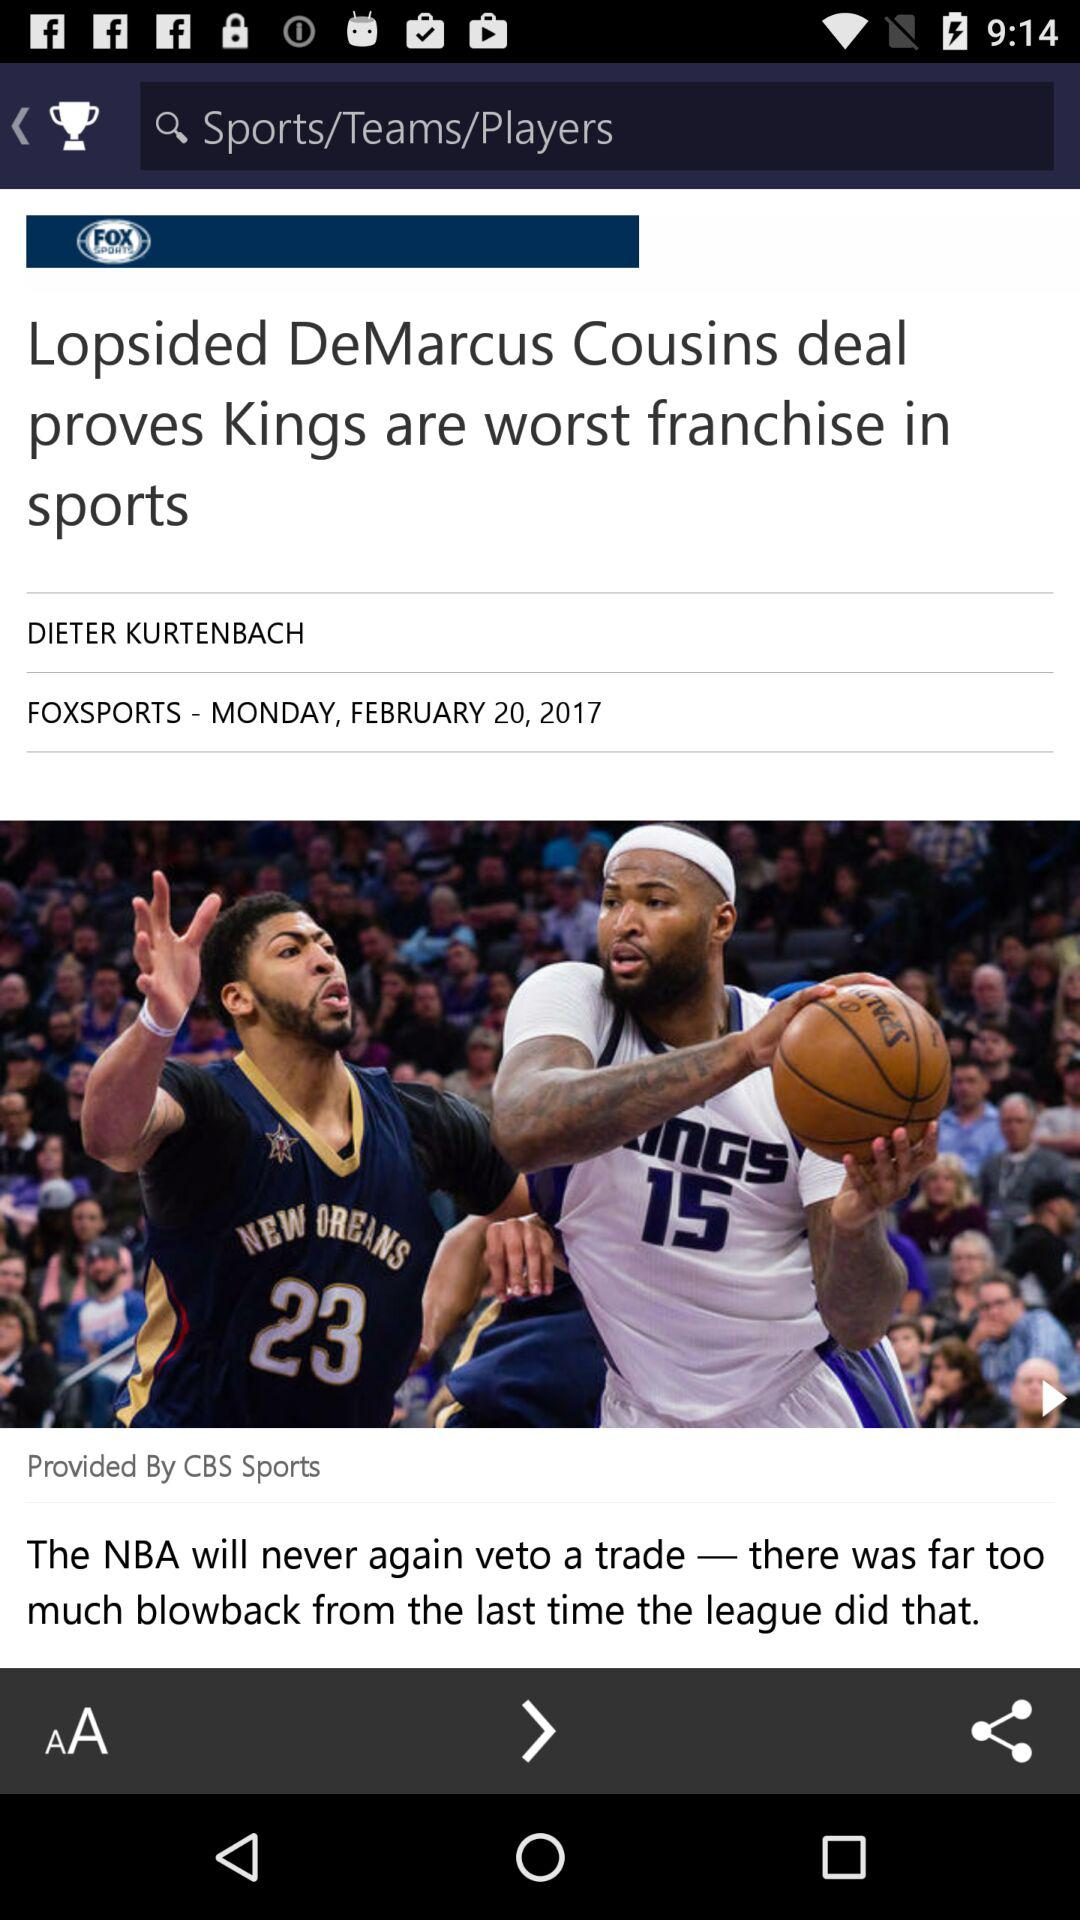What is the publication date of the article? The publication date of the article is Monday, February 20, 2017. 